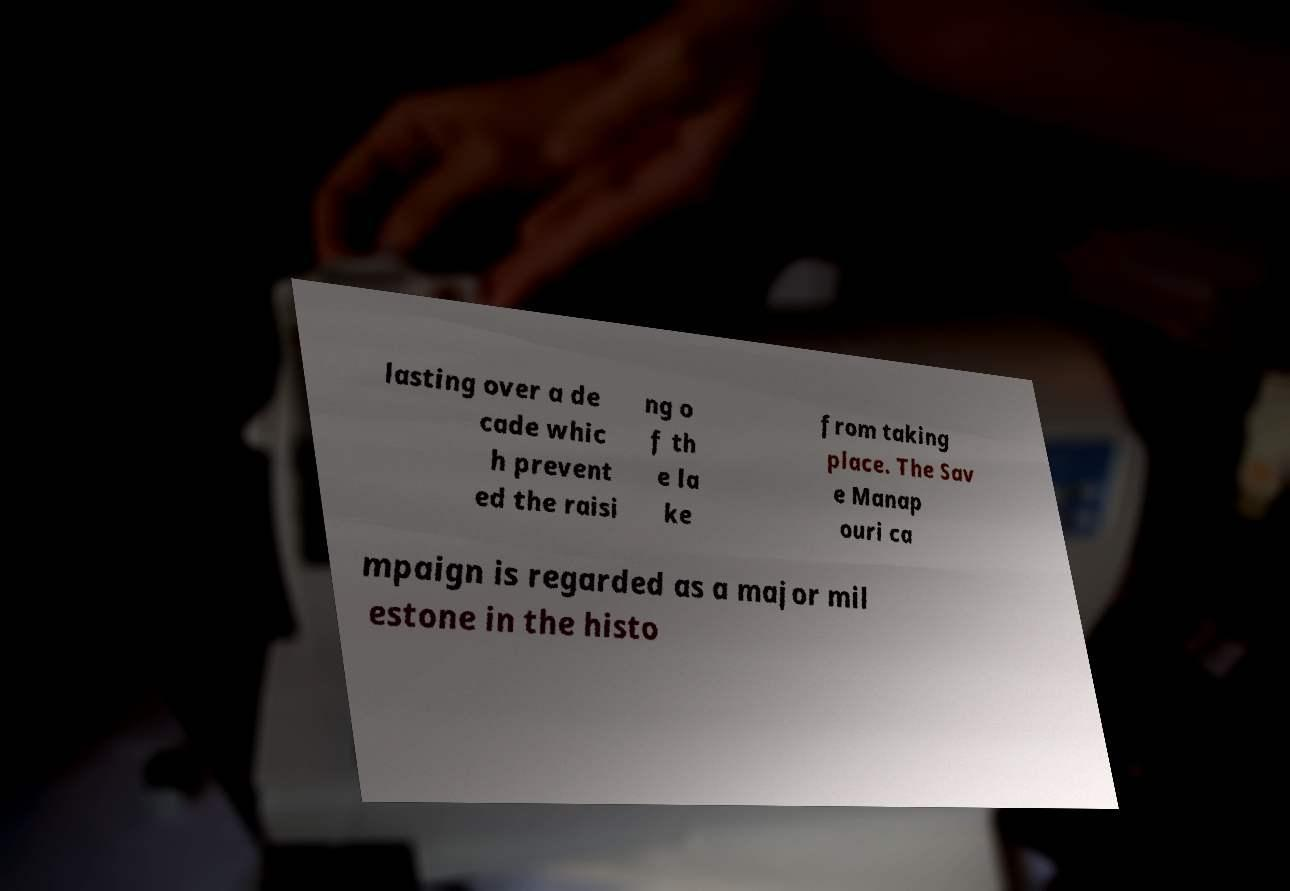Could you extract and type out the text from this image? lasting over a de cade whic h prevent ed the raisi ng o f th e la ke from taking place. The Sav e Manap ouri ca mpaign is regarded as a major mil estone in the histo 